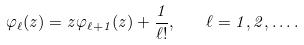<formula> <loc_0><loc_0><loc_500><loc_500>\varphi _ { \ell } ( z ) = z \varphi _ { \ell + 1 } ( z ) + \frac { 1 } { \ell ! } , \quad \ell = 1 , 2 , \dots .</formula> 